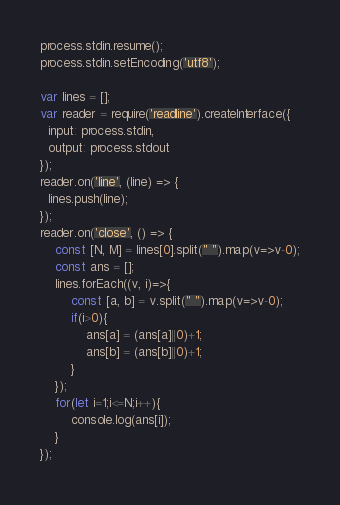Convert code to text. <code><loc_0><loc_0><loc_500><loc_500><_JavaScript_>process.stdin.resume();
process.stdin.setEncoding('utf8');

var lines = [];
var reader = require('readline').createInterface({
  input: process.stdin,
  output: process.stdout
});
reader.on('line', (line) => {
  lines.push(line);
});
reader.on('close', () => {
    const [N, M] = lines[0].split(" ").map(v=>v-0);
    const ans = [];
    lines.forEach((v, i)=>{
        const [a, b] = v.split(" ").map(v=>v-0);
        if(i>0){
            ans[a] = (ans[a]||0)+1;
            ans[b] = (ans[b]||0)+1;
        }
    });
    for(let i=1;i<=N;i++){
        console.log(ans[i]);
    }
});
</code> 